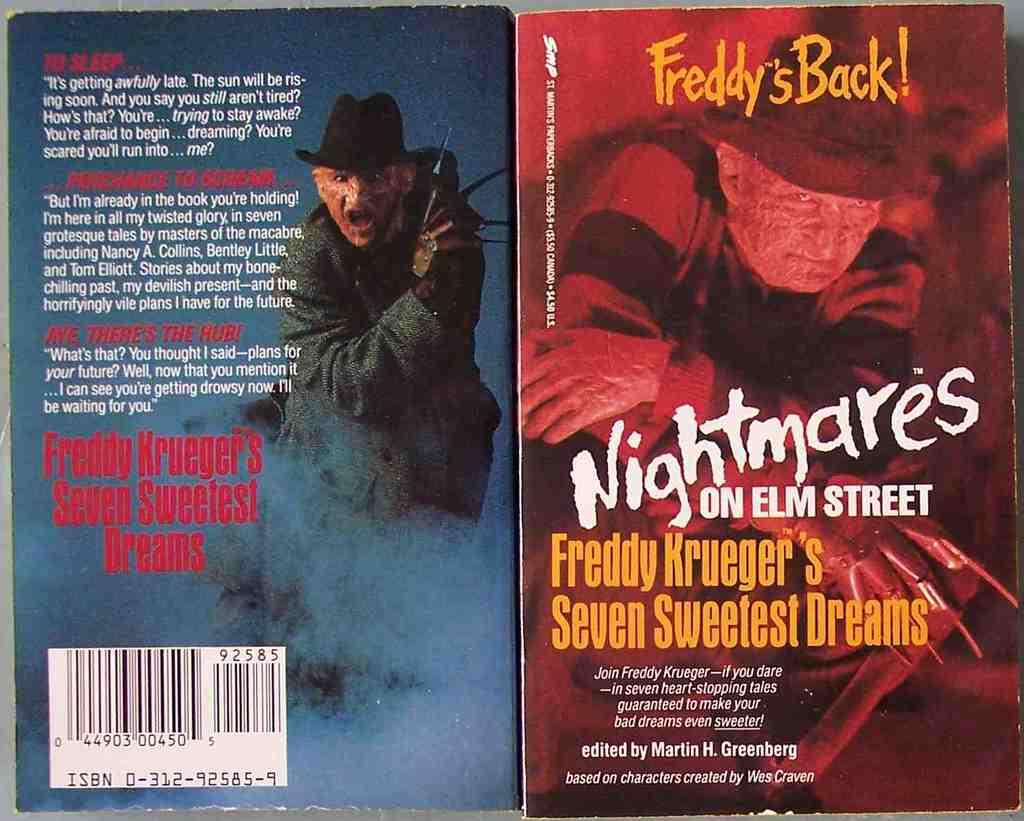Who is the protagonist in this book?
Your answer should be compact. Freddy krueger. What movie are these books from?
Your answer should be compact. Nightmare on elm street. 